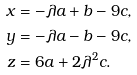<formula> <loc_0><loc_0><loc_500><loc_500>x & = - \lambda a + b - 9 c , \\ y & = - \lambda a - b - 9 c , \\ z & = 6 a + 2 \lambda ^ { 2 } c .</formula> 